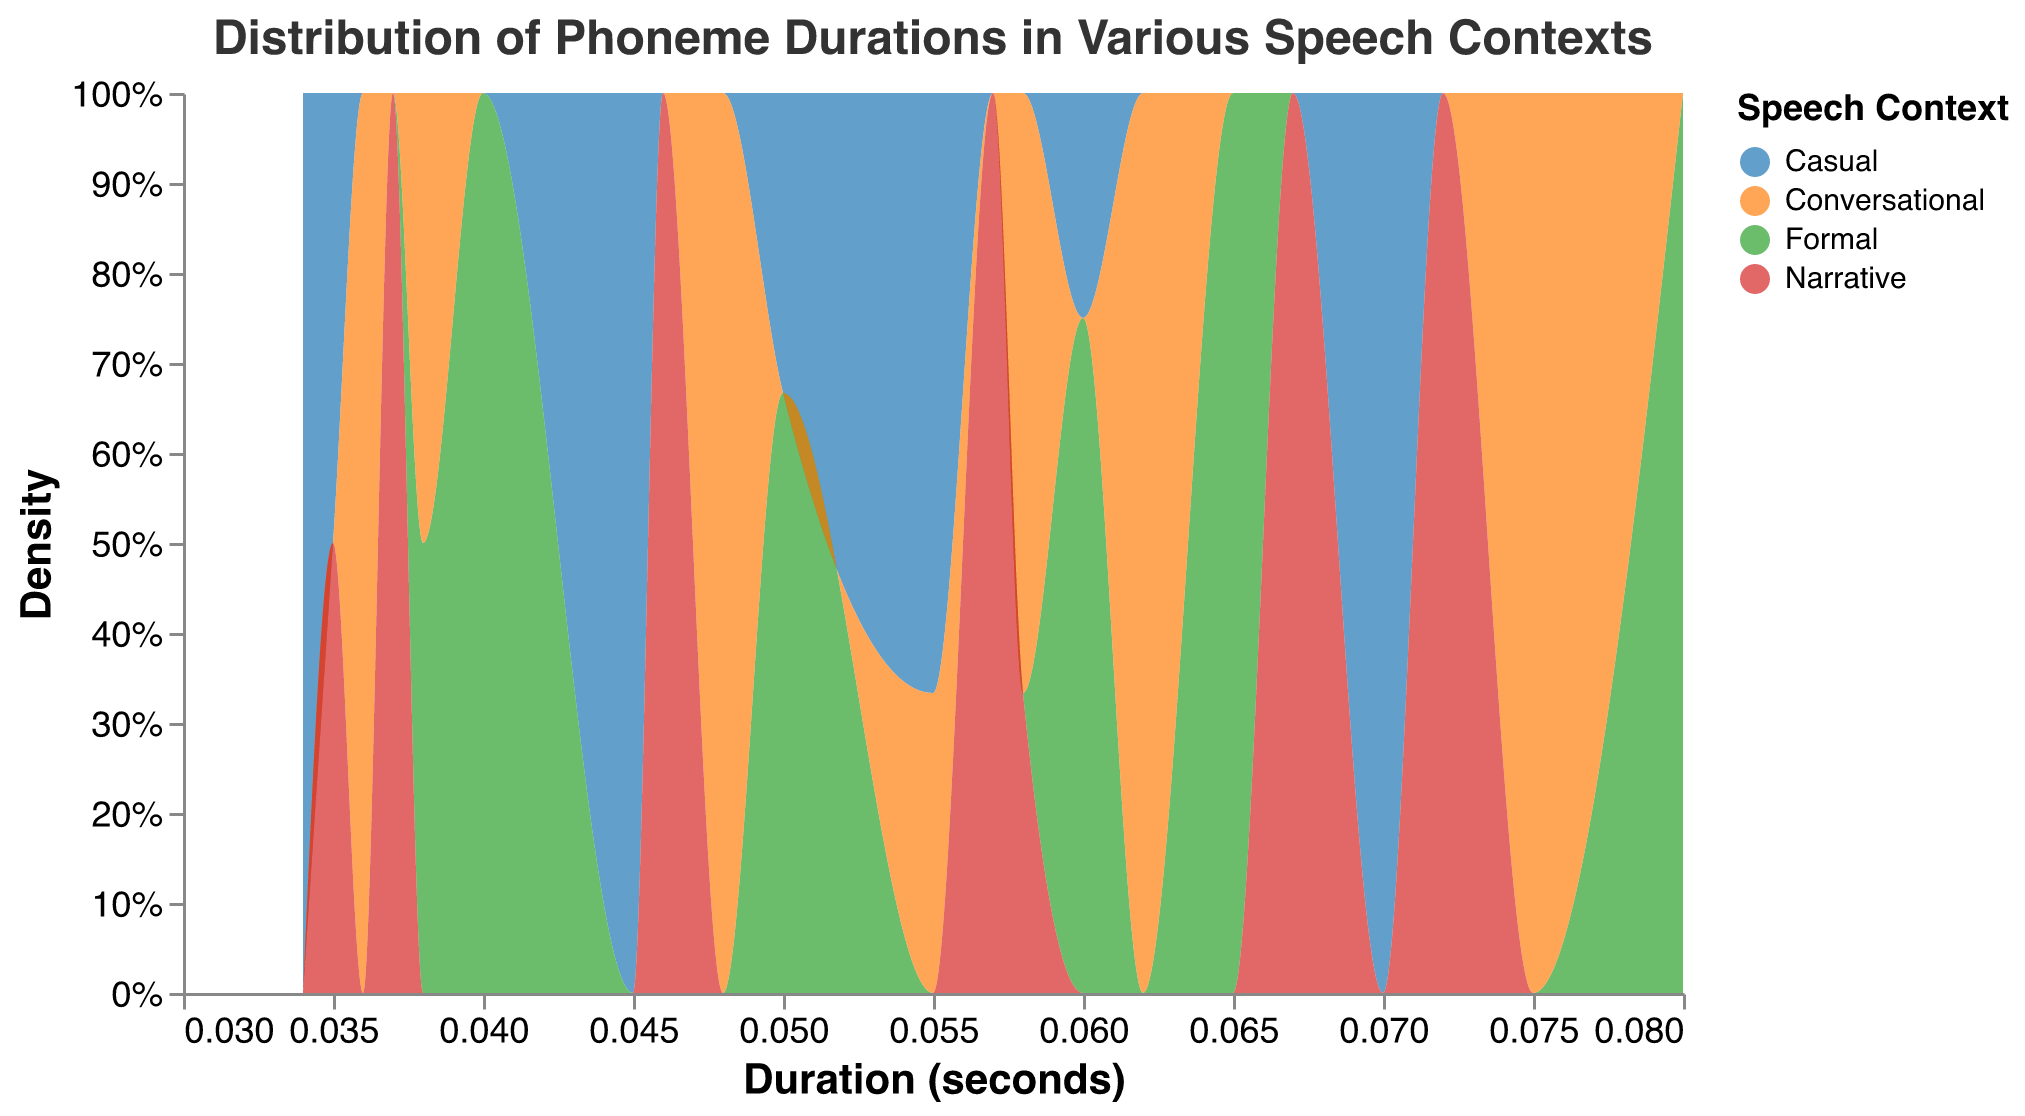What's the title of the figure? The title is displayed prominently at the top of the figure. It reads "Distribution of Phoneme Durations in Various Speech Contexts."
Answer: Distribution of Phoneme Durations in Various Speech Contexts What are the four speech contexts shown in the legend? The legend lists the four different speech contexts, which are displayed in distinct colors. The contexts are Casual, Formal, Conversational, and Narrative.
Answer: Casual, Formal, Conversational, Narrative What is the horizontal axis representing? The label on the horizontal axis indicates that it represents the "Duration (seconds)" of phonemes.
Answer: Duration (seconds) Which context has the highest density for phoneme duration around 0.06 seconds? By examining the area under the curve near the 0.06-second mark on the horizontal axis, we can see that the Formal context has the highest density since its area is most prominent at this duration.
Answer: Formal Which phoneme has the longest duration across all contexts? By observing the figure and focusing on the extended areas, we notice that the phoneme /A/ tends to have the longest duration in all contexts, averaging around 0.07 to 0.08 seconds.
Answer: /A/ Compare the densities of /U/ in Casual and Narrative contexts. Which is higher at around 0.065 seconds? When looking at the densities for /U/ at approximately 0.065 seconds, the Narrative context shows a higher density than the Casual context, as indicated by the larger area in that region for Narrative.
Answer: Narrative What's the difference in average duration between /E/ in Casual and Formal contexts? The average duration for /E/ in Casual context is 0.045 seconds and for Formal context is 0.05 seconds. The difference is calculated as 0.05 - 0.045 = 0.005 seconds.
Answer: 0.005 seconds For which speech context do /R/ and /O/ have similar duration densities? Observing the areas under the curves, /R/ and /O/ have similar duration densities for the Narrative context, as their distributions overlap significantly.
Answer: Narrative How does the density distribution of phoneme durations in the Conversational context compare to the Casual context? The density distribution for the Conversational context generally shows more intermediate durations (closer to 0.055 - 0.075 seconds), whereas the Casual context shows a broader spread with some shorter and some longer durations (around 0.035 - 0.070 seconds).
Answer: More intermediate durations in Conversational, broader spread in Casual 